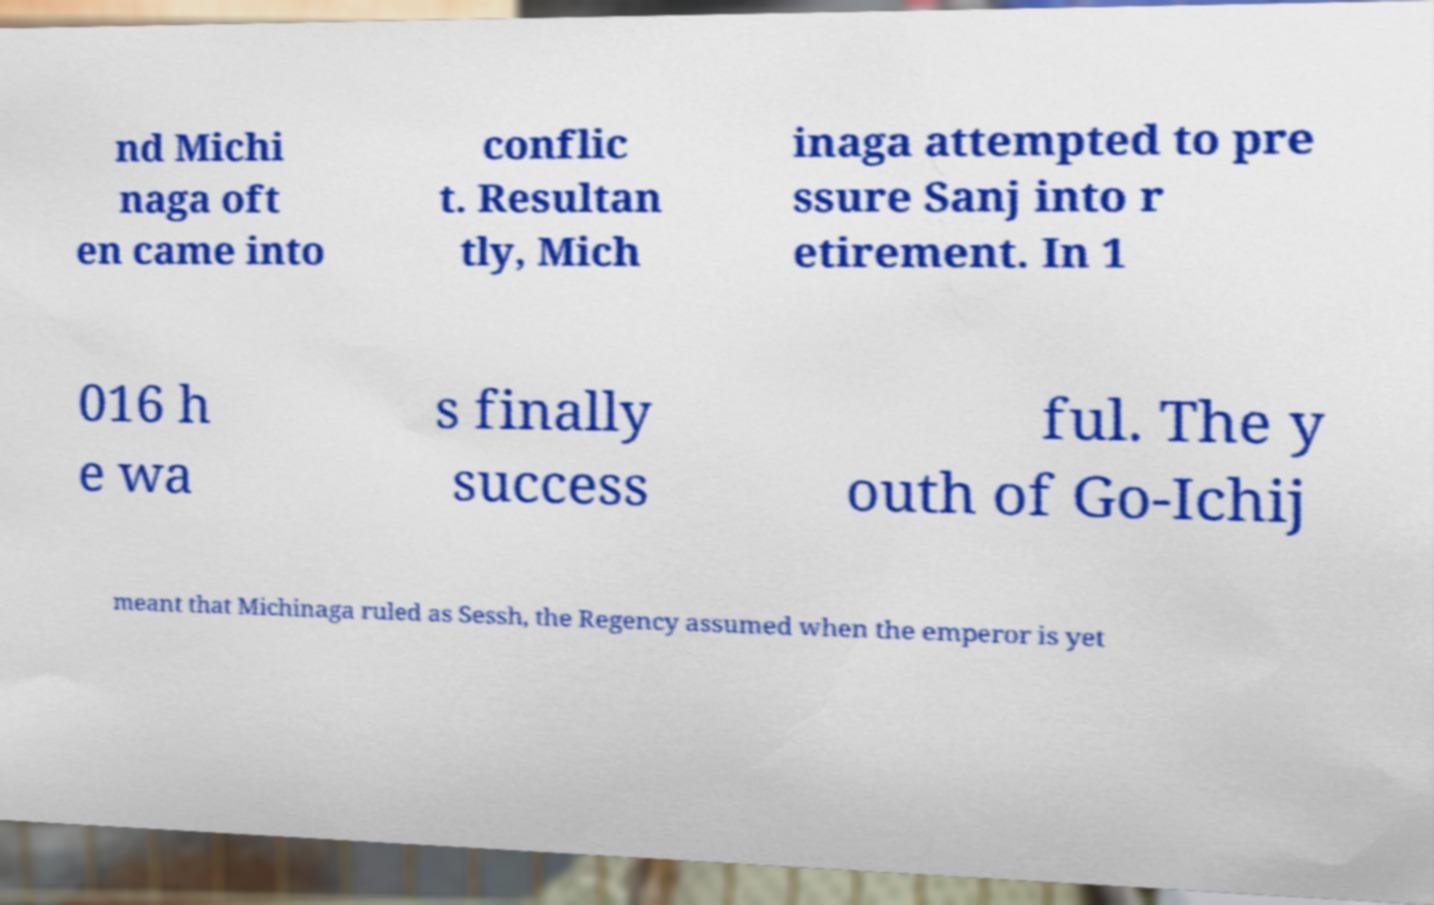There's text embedded in this image that I need extracted. Can you transcribe it verbatim? nd Michi naga oft en came into conflic t. Resultan tly, Mich inaga attempted to pre ssure Sanj into r etirement. In 1 016 h e wa s finally success ful. The y outh of Go-Ichij meant that Michinaga ruled as Sessh, the Regency assumed when the emperor is yet 